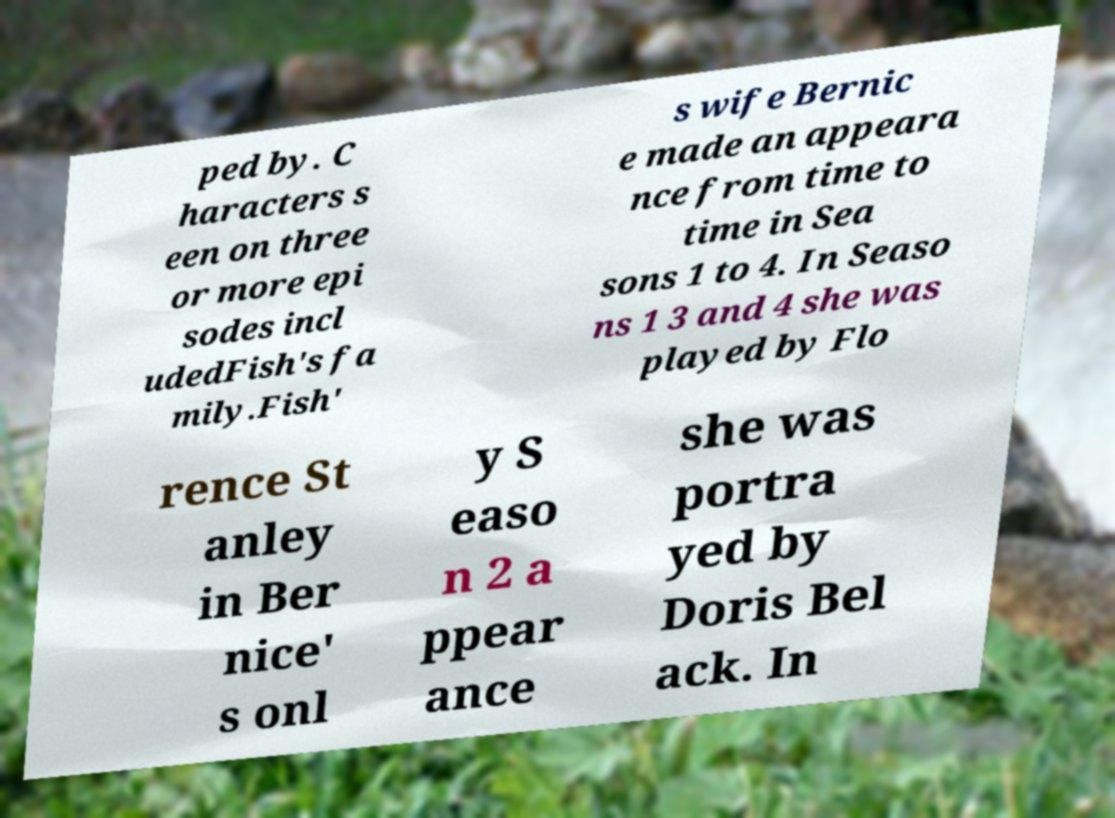Could you assist in decoding the text presented in this image and type it out clearly? ped by. C haracters s een on three or more epi sodes incl udedFish's fa mily.Fish' s wife Bernic e made an appeara nce from time to time in Sea sons 1 to 4. In Seaso ns 1 3 and 4 she was played by Flo rence St anley in Ber nice' s onl y S easo n 2 a ppear ance she was portra yed by Doris Bel ack. In 